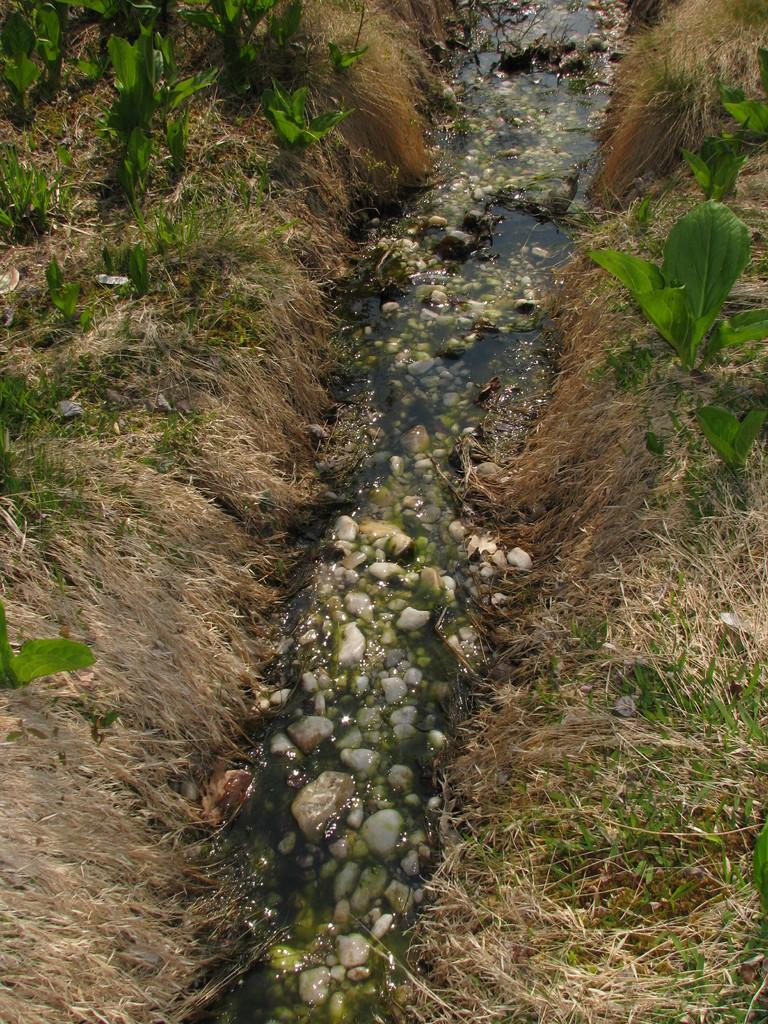What is the main feature in the center of the image? There is water in the center of the image. What can be found within the water? There are stones in the water. What type of vegetation is present on the left side of the image? There are plants on the left side of the image. What is the condition of the grass on the right side of the image? There is dry grass on the right side of the image. Are there any plants on the right side of the image? Yes, there are plants on the right side of the image as well. What type of butter is being used to create the cave in the image? There is no butter or cave present in the image. 